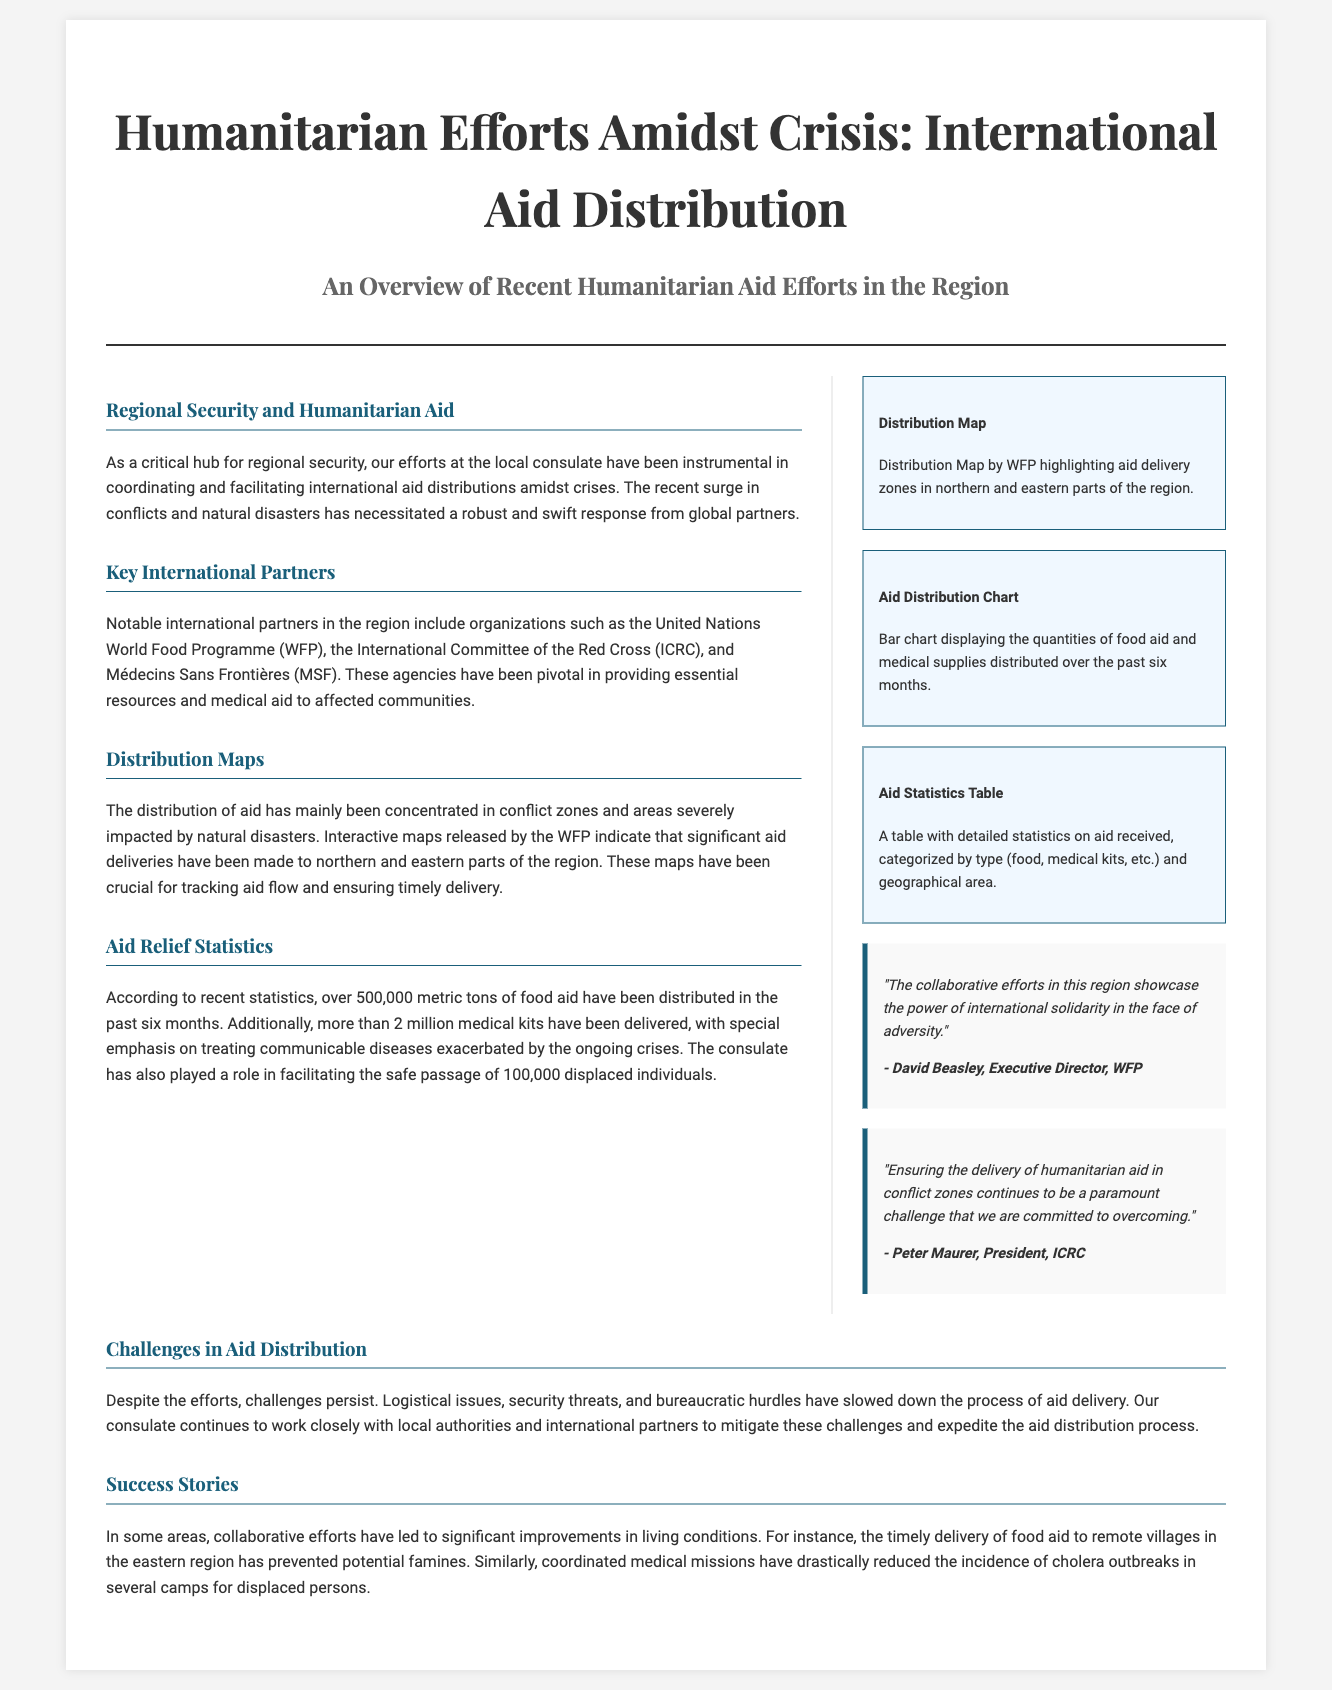What is the title of the document? The title of the document is prominently displayed at the top of the page.
Answer: Humanitarian Efforts Amidst Crisis: International Aid Distribution Who is one of the key international partners mentioned? The document lists specific organizations as partners in humanitarian efforts in the region.
Answer: United Nations World Food Programme (WFP) How many metric tons of food aid have been distributed in the past six months? The document provides a specific statistic related to food aid distribution within a timeframe.
Answer: 500,000 metric tons What is a major challenge in aid distribution mentioned? The document highlights specific obstacles faced during the aid distribution process.
Answer: Logistical issues Which region received significant aid deliveries? The document indicates the geographical areas most affected and receiving aid.
Answer: Northern and eastern parts of the region Who provided a quote about international solidarity? The document includes quotes from key individuals in international organizations, specifying their contributions to aid efforts.
Answer: David Beasley What type of infographic is suggested to display the quantities of supplies? The sidebar mentions different types of infographics used for data representation.
Answer: Aid Distribution Chart What role does the consulate play in humanitarian efforts mentioned in the document? The document describes the involvement of the consulate in aid distribution and coordination.
Answer: Facilitating international aid distributions 